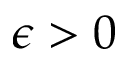<formula> <loc_0><loc_0><loc_500><loc_500>\epsilon > 0</formula> 